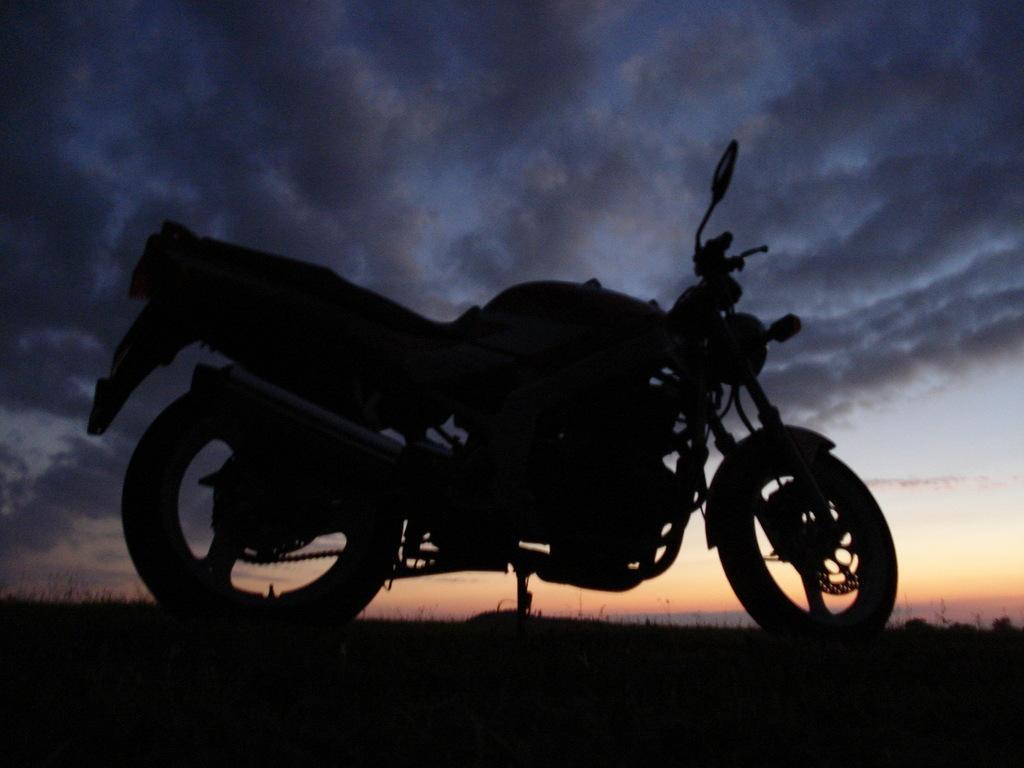In one or two sentences, can you explain what this image depicts? This image is taken outdoors. At the top of the image there is the sky with clouds. At the bottom of the image there is a ground. In the middle of the image a bike is parked on the ground. 